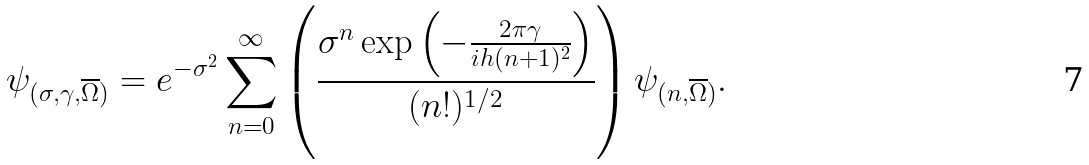<formula> <loc_0><loc_0><loc_500><loc_500>\psi _ { ( \sigma , \gamma , \overline { \Omega } ) } = e ^ { - \sigma ^ { 2 } } \sum _ { n = 0 } ^ { \infty } \left ( \frac { \sigma ^ { n } \exp \left ( - \frac { 2 \pi \gamma } { i h ( n + 1 ) ^ { 2 } } \right ) } { ( n ! ) ^ { 1 / 2 } } \right ) \psi _ { ( n , \overline { \Omega } ) } .</formula> 